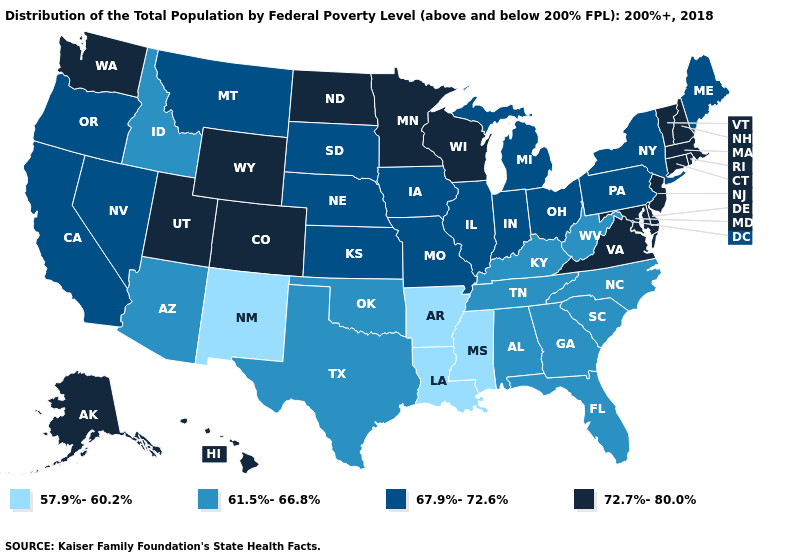Which states have the lowest value in the USA?
Quick response, please. Arkansas, Louisiana, Mississippi, New Mexico. Among the states that border Montana , which have the lowest value?
Short answer required. Idaho. What is the lowest value in the MidWest?
Concise answer only. 67.9%-72.6%. Name the states that have a value in the range 67.9%-72.6%?
Answer briefly. California, Illinois, Indiana, Iowa, Kansas, Maine, Michigan, Missouri, Montana, Nebraska, Nevada, New York, Ohio, Oregon, Pennsylvania, South Dakota. What is the highest value in the USA?
Give a very brief answer. 72.7%-80.0%. Name the states that have a value in the range 72.7%-80.0%?
Quick response, please. Alaska, Colorado, Connecticut, Delaware, Hawaii, Maryland, Massachusetts, Minnesota, New Hampshire, New Jersey, North Dakota, Rhode Island, Utah, Vermont, Virginia, Washington, Wisconsin, Wyoming. What is the highest value in states that border Montana?
Write a very short answer. 72.7%-80.0%. What is the lowest value in the Northeast?
Answer briefly. 67.9%-72.6%. Name the states that have a value in the range 61.5%-66.8%?
Give a very brief answer. Alabama, Arizona, Florida, Georgia, Idaho, Kentucky, North Carolina, Oklahoma, South Carolina, Tennessee, Texas, West Virginia. Is the legend a continuous bar?
Answer briefly. No. Does Michigan have the lowest value in the MidWest?
Answer briefly. Yes. Which states have the highest value in the USA?
Concise answer only. Alaska, Colorado, Connecticut, Delaware, Hawaii, Maryland, Massachusetts, Minnesota, New Hampshire, New Jersey, North Dakota, Rhode Island, Utah, Vermont, Virginia, Washington, Wisconsin, Wyoming. Name the states that have a value in the range 72.7%-80.0%?
Give a very brief answer. Alaska, Colorado, Connecticut, Delaware, Hawaii, Maryland, Massachusetts, Minnesota, New Hampshire, New Jersey, North Dakota, Rhode Island, Utah, Vermont, Virginia, Washington, Wisconsin, Wyoming. Does Hawaii have a higher value than New Mexico?
Quick response, please. Yes. Name the states that have a value in the range 67.9%-72.6%?
Write a very short answer. California, Illinois, Indiana, Iowa, Kansas, Maine, Michigan, Missouri, Montana, Nebraska, Nevada, New York, Ohio, Oregon, Pennsylvania, South Dakota. 